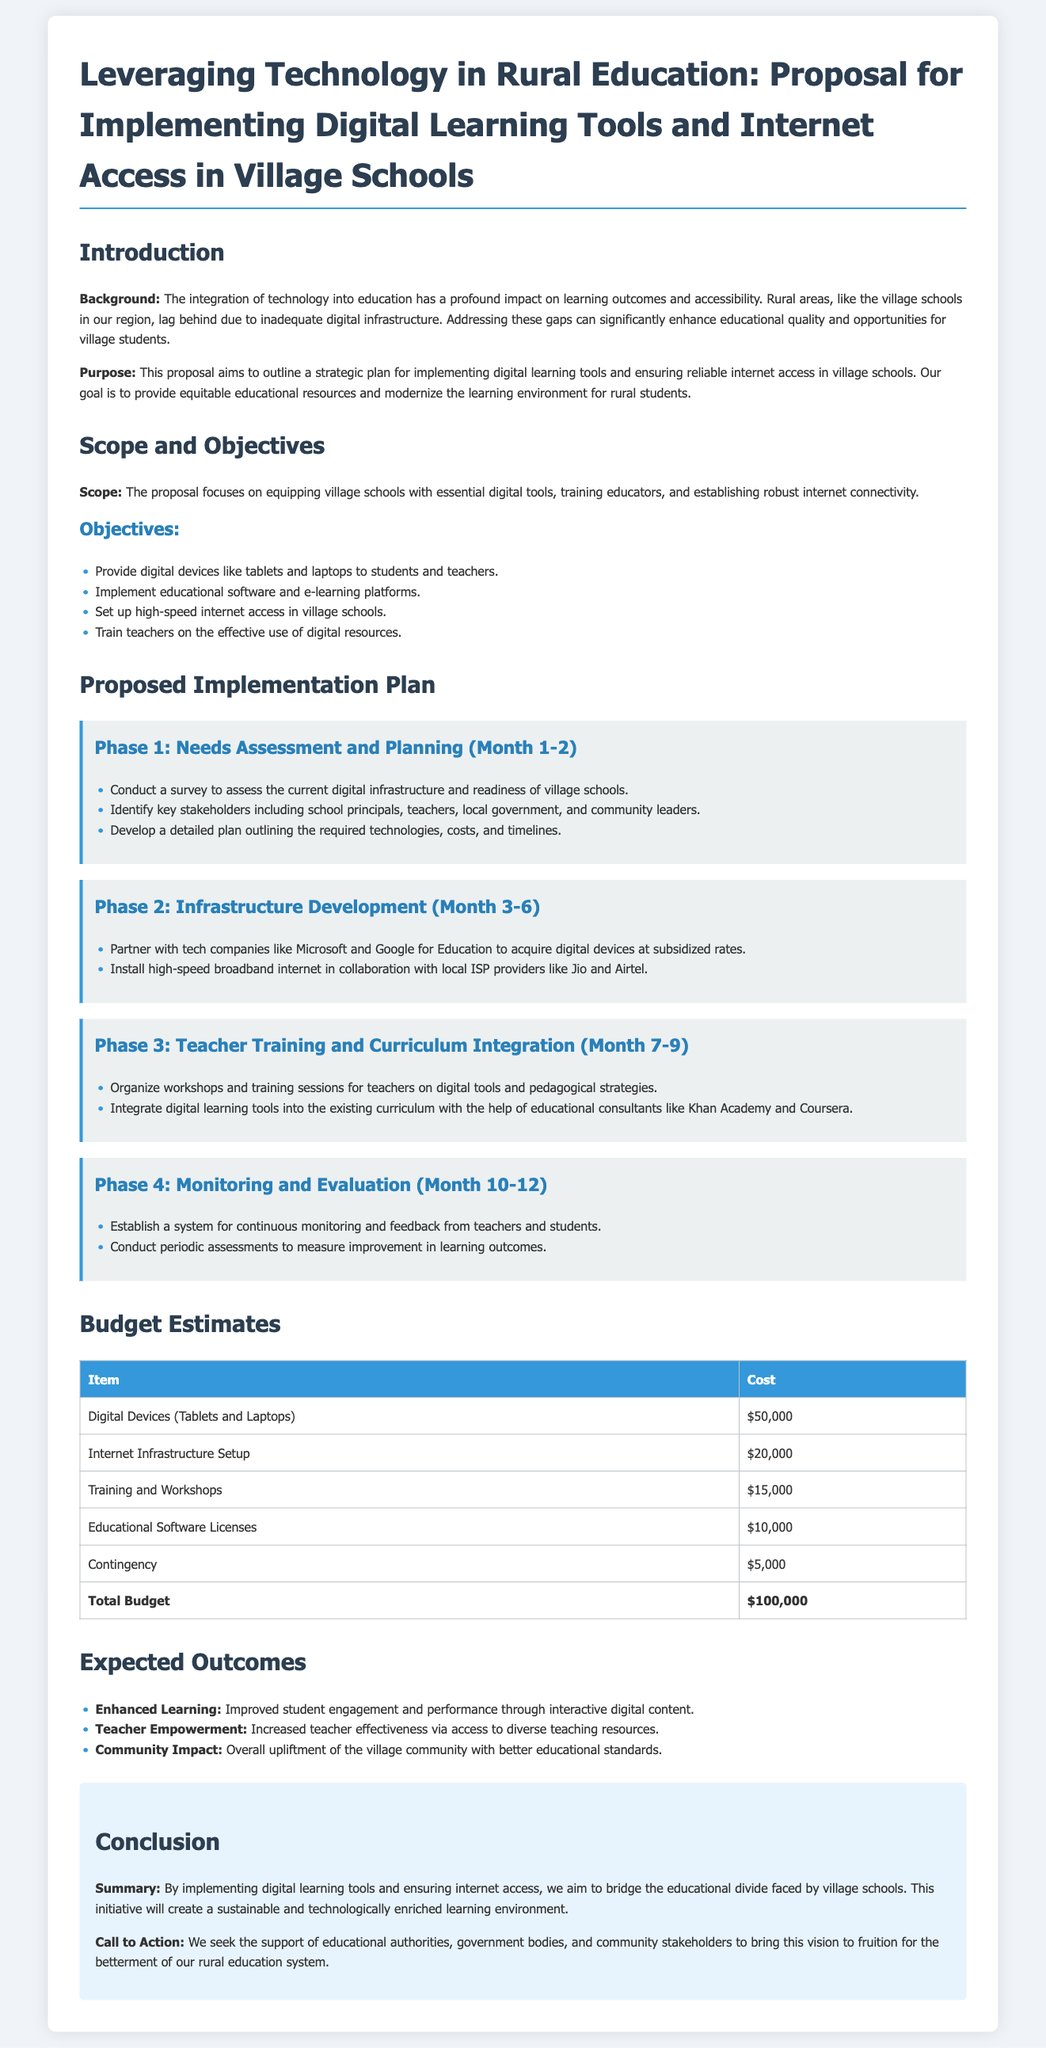What is the total budget for the proposal? The total budget is presented in the budget estimates section, which sums up to $100,000.
Answer: $100,000 What are the key stakeholders identified in the proposal? The stakeholders include school principals, teachers, local government, and community leaders, as mentioned in the needs assessment.
Answer: School principals, teachers, local government, community leaders What is the cost allocation for training and workshops? The cost for training and workshops is specified in the budget estimates section as $15,000.
Answer: $15,000 Which companies are mentioned as partners for acquiring digital devices? The partnership with tech companies like Microsoft and Google for Education is highlighted for acquiring digital devices.
Answer: Microsoft, Google for Education During which phase will teacher training take place? Teacher training occurs in Phase 3, as detailed in the implementation plan.
Answer: Phase 3 What is the purpose of the proposal? The purpose, stated in the document, is to outline a strategic plan for implementing digital learning tools and ensuring internet access.
Answer: Outline a strategic plan for implementing digital learning tools and ensuring internet access What is one expected outcome of implementing digital learning tools? The proposal mentions improved student engagement and performance as an expected outcome.
Answer: Improved student engagement and performance How long is the needs assessment and planning phase scheduled to last? The needs assessment and planning phase is scheduled for 2 months, as indicated in the implementation plan timeline.
Answer: 2 months 